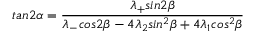<formula> <loc_0><loc_0><loc_500><loc_500>t a n 2 \alpha = \frac { \lambda _ { + } \sin 2 \beta } { \lambda _ { - } \cos 2 \beta - 4 \lambda _ { 2 } \sin ^ { 2 } \beta + 4 \lambda _ { 1 } \cos ^ { 2 } \beta } \,</formula> 